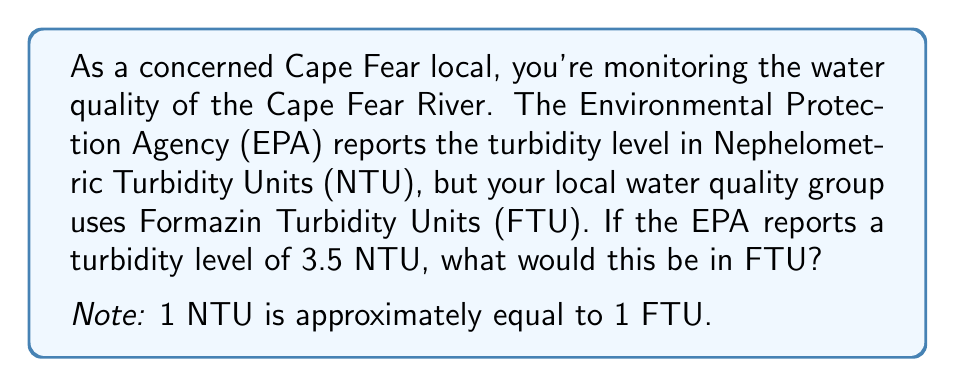Could you help me with this problem? To convert between NTU and FTU, we need to understand the relationship between these units:

1 NTU ≈ 1 FTU

This means that the numerical value remains the same when converting from NTU to FTU. Therefore, we can set up a simple equation:

$$ 3.5 \text{ NTU} = x \text{ FTU} $$

Since the relationship is 1:1, we can directly transfer the numerical value:

$$ x = 3.5 \text{ FTU} $$

This conversion is straightforward because NTU and FTU are essentially equivalent units for measuring turbidity. Both units are based on the scattering of light by suspended particles in water, which is why they're interchangeable in most practical applications.

It's important to note that while this 1:1 relationship is generally accepted for practical purposes, there can be slight variations in extremely precise measurements due to differences in the specific methods and standards used. However, for most water quality monitoring purposes, including those relevant to the Cape Fear River, this approximation is more than sufficient.
Answer: 3.5 FTU 